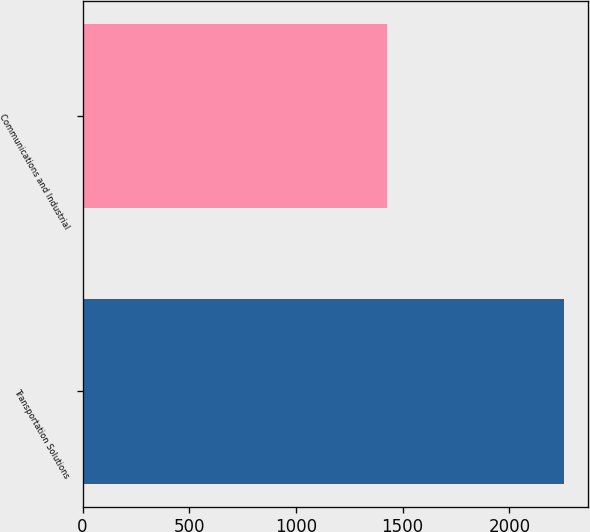Convert chart. <chart><loc_0><loc_0><loc_500><loc_500><bar_chart><fcel>Transportation Solutions<fcel>Communications and Industrial<nl><fcel>2254<fcel>1428<nl></chart> 